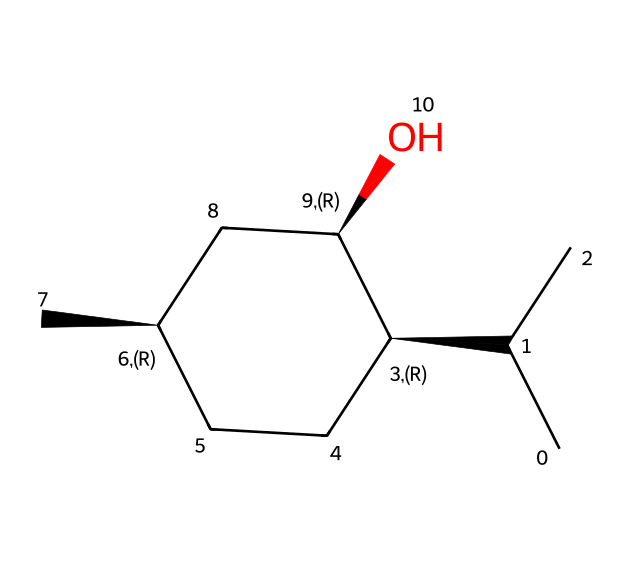What is the chemical name of this compound? The SMILES representation provided corresponds to menthol, a common organic compound known for its minty flavor and odor.
Answer: menthol How many carbon atoms are present in this molecule? By analyzing the SMILES representation, there are a total of ten carbon (C) atoms depicted in the structure.
Answer: ten What type of functional group is present in menthol? The OH group in the structure indicates the presence of an alcohol functional group, which is characteristic of menthol.
Answer: alcohol What is the degree of branching observed in this molecule? The structure shows multiple branched carbon chains, indicating it has considerable branching, relevant for its cycloalkane nature.
Answer: branched How many chiral centers does menthol have? The structure features three carbon atoms bonded to four different groups, indicating there are three chiral centers within the molecule.
Answer: three What type of structure does menthol exhibit? The cyclic arrangement of carbon atoms along with branching confirms that menthol has a cycloalkane structure.
Answer: cycloalkane What is the stereochemistry of the chiral centers in menthol? The presence of @ symbols in the SMILES notation indicates the specific stereochemistry at the chiral centers, confirming their arrangement is based on standard conventions.
Answer: specific stereochemistry 